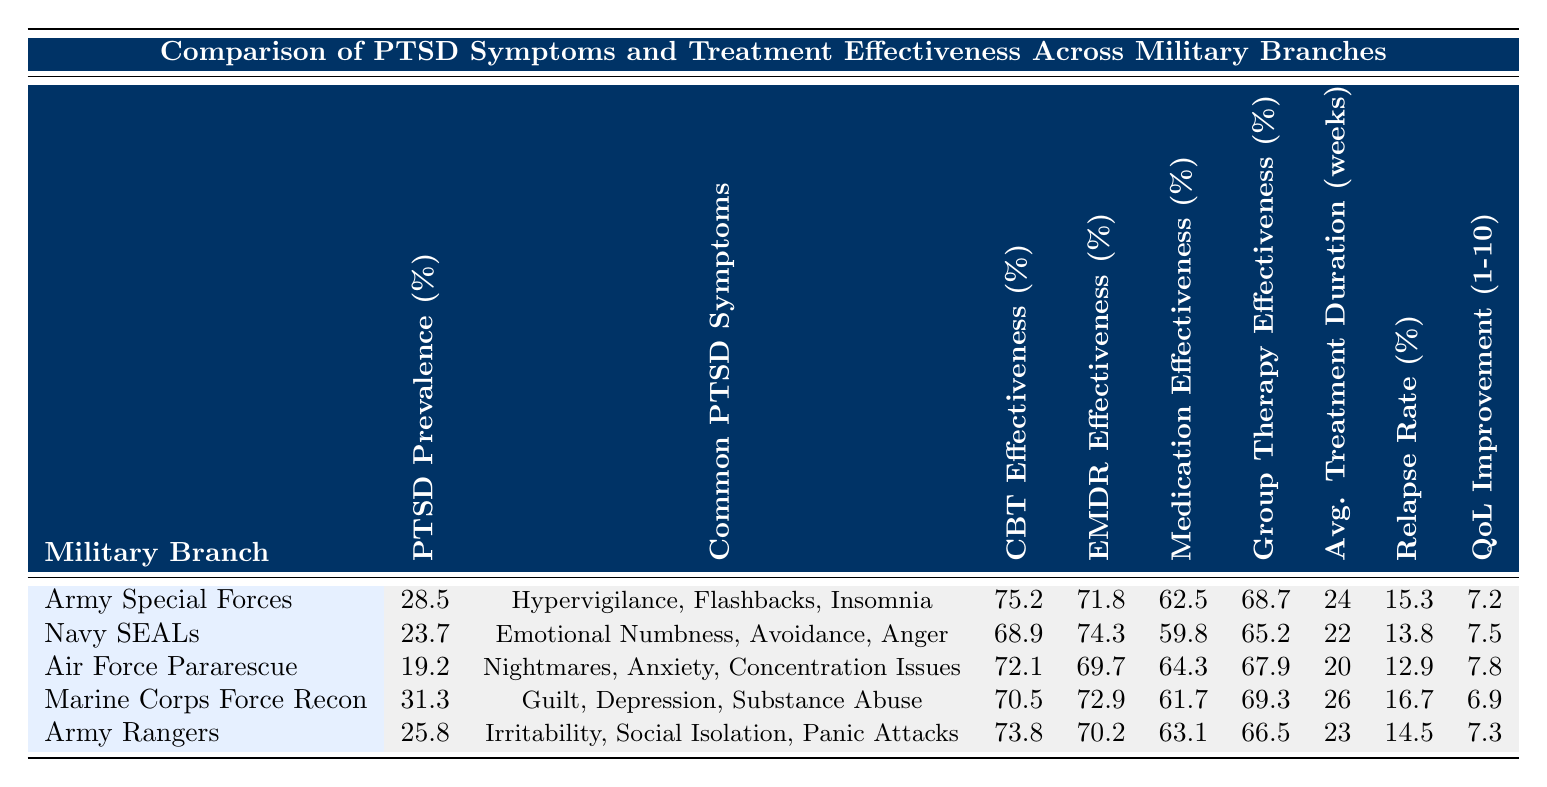What is the PTSD prevalence rate for Marine Corps Force Recon? The table shows that the PTSD prevalence rate for Marine Corps Force Recon is listed directly under the respective column. It reads 31.3%.
Answer: 31.3% Which military branch has the lowest reported quality of life improvement? By comparing the values listed for quality of life improvement, Air Force Pararescue has the highest at 7.8, followed by Navy SEALs at 7.5, Army Rangers at 7.3, Army Special Forces at 7.2, and Marine Corps Force Recon at 6.9. Marine Corps Force Recon has the lowest.
Answer: Marine Corps Force Recon What is the average treatment duration for Army Rangers? The average treatment duration for Army Rangers is found in the corresponding column in the table, where it is recorded as 23 weeks.
Answer: 23 weeks Which branch has the highest effectiveness for Cognitive Behavioral Therapy (CBT)? The effectiveness rates for CBT are listed for each military branch. Army Special Forces has the highest at 75.2%.
Answer: 75.2% What is the difference in PTSD prevalence rates between Army Special Forces and Air Force Pararescue? The PTSD prevalence rate for Army Special Forces is 28.5% and for Air Force Pararescue, it is 19.2%. The difference is calculated as 28.5 - 19.2 = 9.3.
Answer: 9.3% Is the relapse rate for Navy SEALs lower than for Marines? The relapse rate for Navy SEALs is 13.8% while for Marine Corps Force Recon it is 16.7%. Since 13.8% is less than 16.7%, the statement is true.
Answer: Yes Which military branch shows the highest effectiveness in EMDR therapy? The EMDR therapy effectiveness is compared across the branches, with Navy SEALs showing the highest effectiveness at 74.3%.
Answer: 74.3% Calculate the average relapse rate across all military branches. The relapse rates are 15.3, 13.8, 12.9, 16.7, and 14.5. The sum is 73.2 and dividing by the number of branches (5) gives an average of 14.64%.
Answer: 14.64% Which military branch between Army Rangers and Navy SEALs has higher group therapy effectiveness? Army Rangers has 66.5% while Navy SEALs has 65.2%. Comparing these two values shows that Army Rangers has higher group therapy effectiveness.
Answer: Army Rangers What is the most common PTSD symptom reported by Air Force Pararescue? The symptoms reported by Air Force Pararescue include nightmares, anxiety, and concentration issues. The entry can be found directly in the table under the symptoms column.
Answer: Nightmares, Anxiety, Concentration Issues 